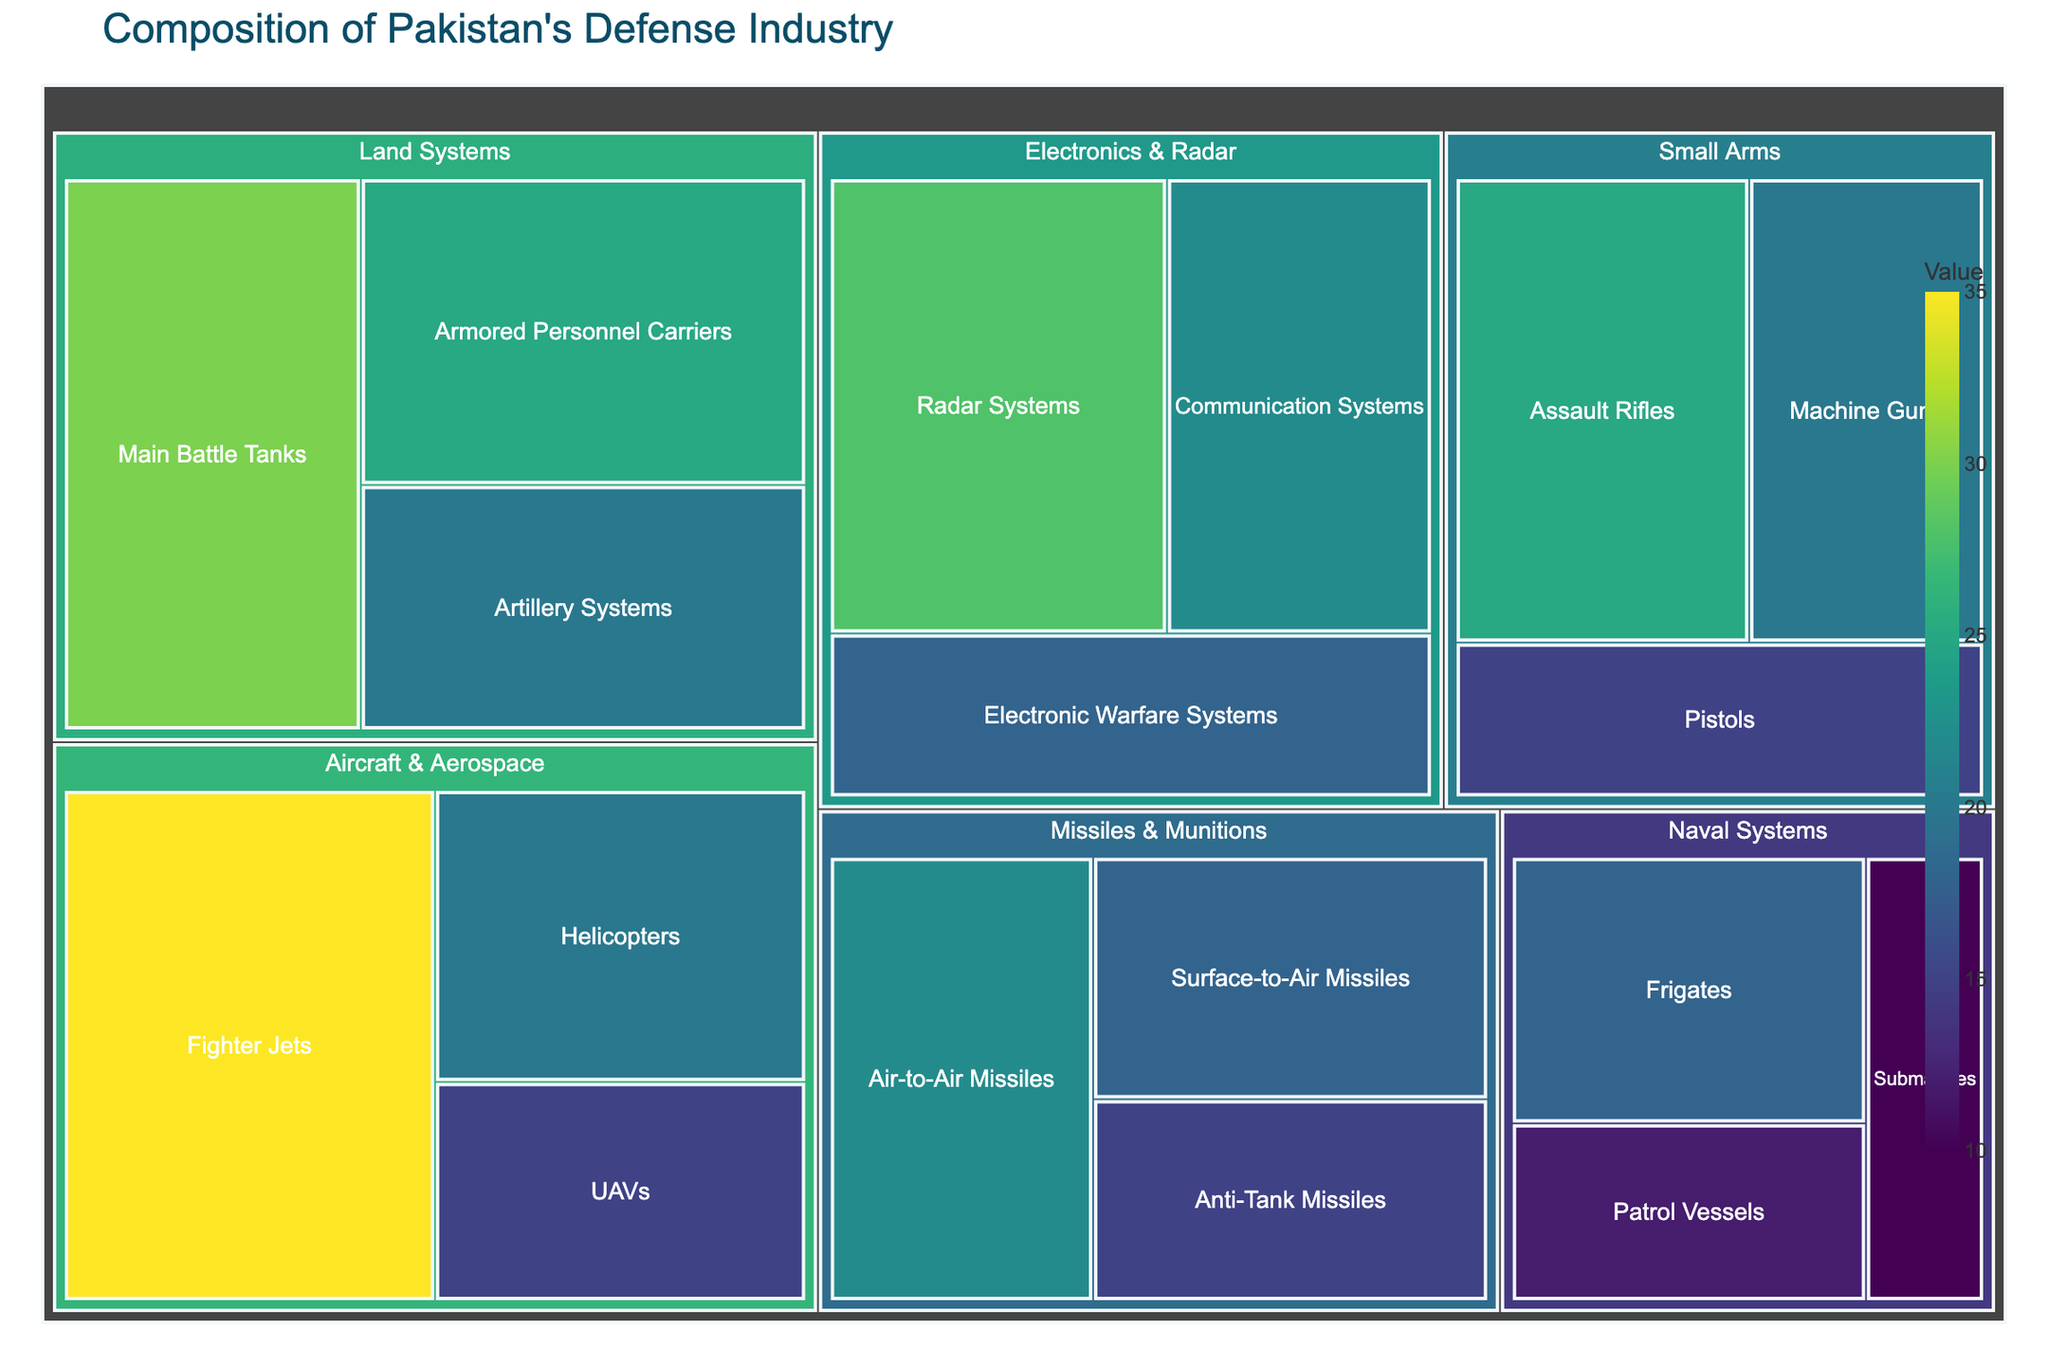What is the largest subcategory in the 'Aircraft & Aerospace' category? In the 'Aircraft & Aerospace' category, the largest subcategory is 'Fighter Jets', which can be identified by its larger size and higher value compared to other subcategories in the same category.
Answer: Fighter Jets What is the second largest subcategory in the 'Land Systems' category? In the 'Land Systems' category, 'Armored Personnel Carriers' is the second largest subcategory. This can be identified by comparing the sizes of the subcategories in 'Land Systems' and seeing that it has the second largest value.
Answer: Armored Personnel Carriers How does the value of 'Frigates' in 'Naval Systems' compare to 'Patrol Vessels'? The value of 'Frigates' (18) is greater than that of 'Patrol Vessels' (12). This can be determined by comparing the sizes of these two subcategories within 'Naval Systems'.
Answer: Frigates > Patrol Vessels What is the combined value of all subcategories in the 'Missiles & Munitions' category? To find the combined value of all subcategories in the 'Missiles & Munitions' category, sum the values of 'Air-to-Air Missiles' (22), 'Surface-to-Air Missiles' (18), and 'Anti-Tank Missiles' (15). The sum is 22 + 18 + 15 = 55.
Answer: 55 Which category has the highest total value? To determine the category with the highest total value, sum the values of all subcategories within each category and compare. 'Aircraft & Aerospace' has the highest total value with 35 (Fighter Jets) + 20 (Helicopters) + 15 (UAVs) = 70.
Answer: Aircraft & Aerospace What is the ratio of the value of 'Electronic Warfare Systems' to 'Radar Systems' in the 'Electronics & Radar' category? To find the ratio, compare the values of 'Electronic Warfare Systems' (18) to 'Radar Systems' (28) in 'Electronics & Radar'. The ratio is 18:28, which simplifies to 9:14.
Answer: 9:14 How do the values of 'Assault Rifles' and 'Main Battle Tanks' compare? Comparing the values of 'Assault Rifles' (25) and 'Main Battle Tanks' (30), we can see that 'Main Battle Tanks' has a higher value than 'Assault Rifles'.
Answer: Main Battle Tanks > Assault Rifles What is the average value of subcategories within the 'Small Arms' category? To find the average value of subcategories in 'Small Arms', sum the values of 'Assault Rifles' (25), 'Machine Guns' (20), and 'Pistols' (15), then divide by the number of subcategories. The sum is 25 + 20 + 15 = 60, and the average is 60/3 = 20.
Answer: 20 